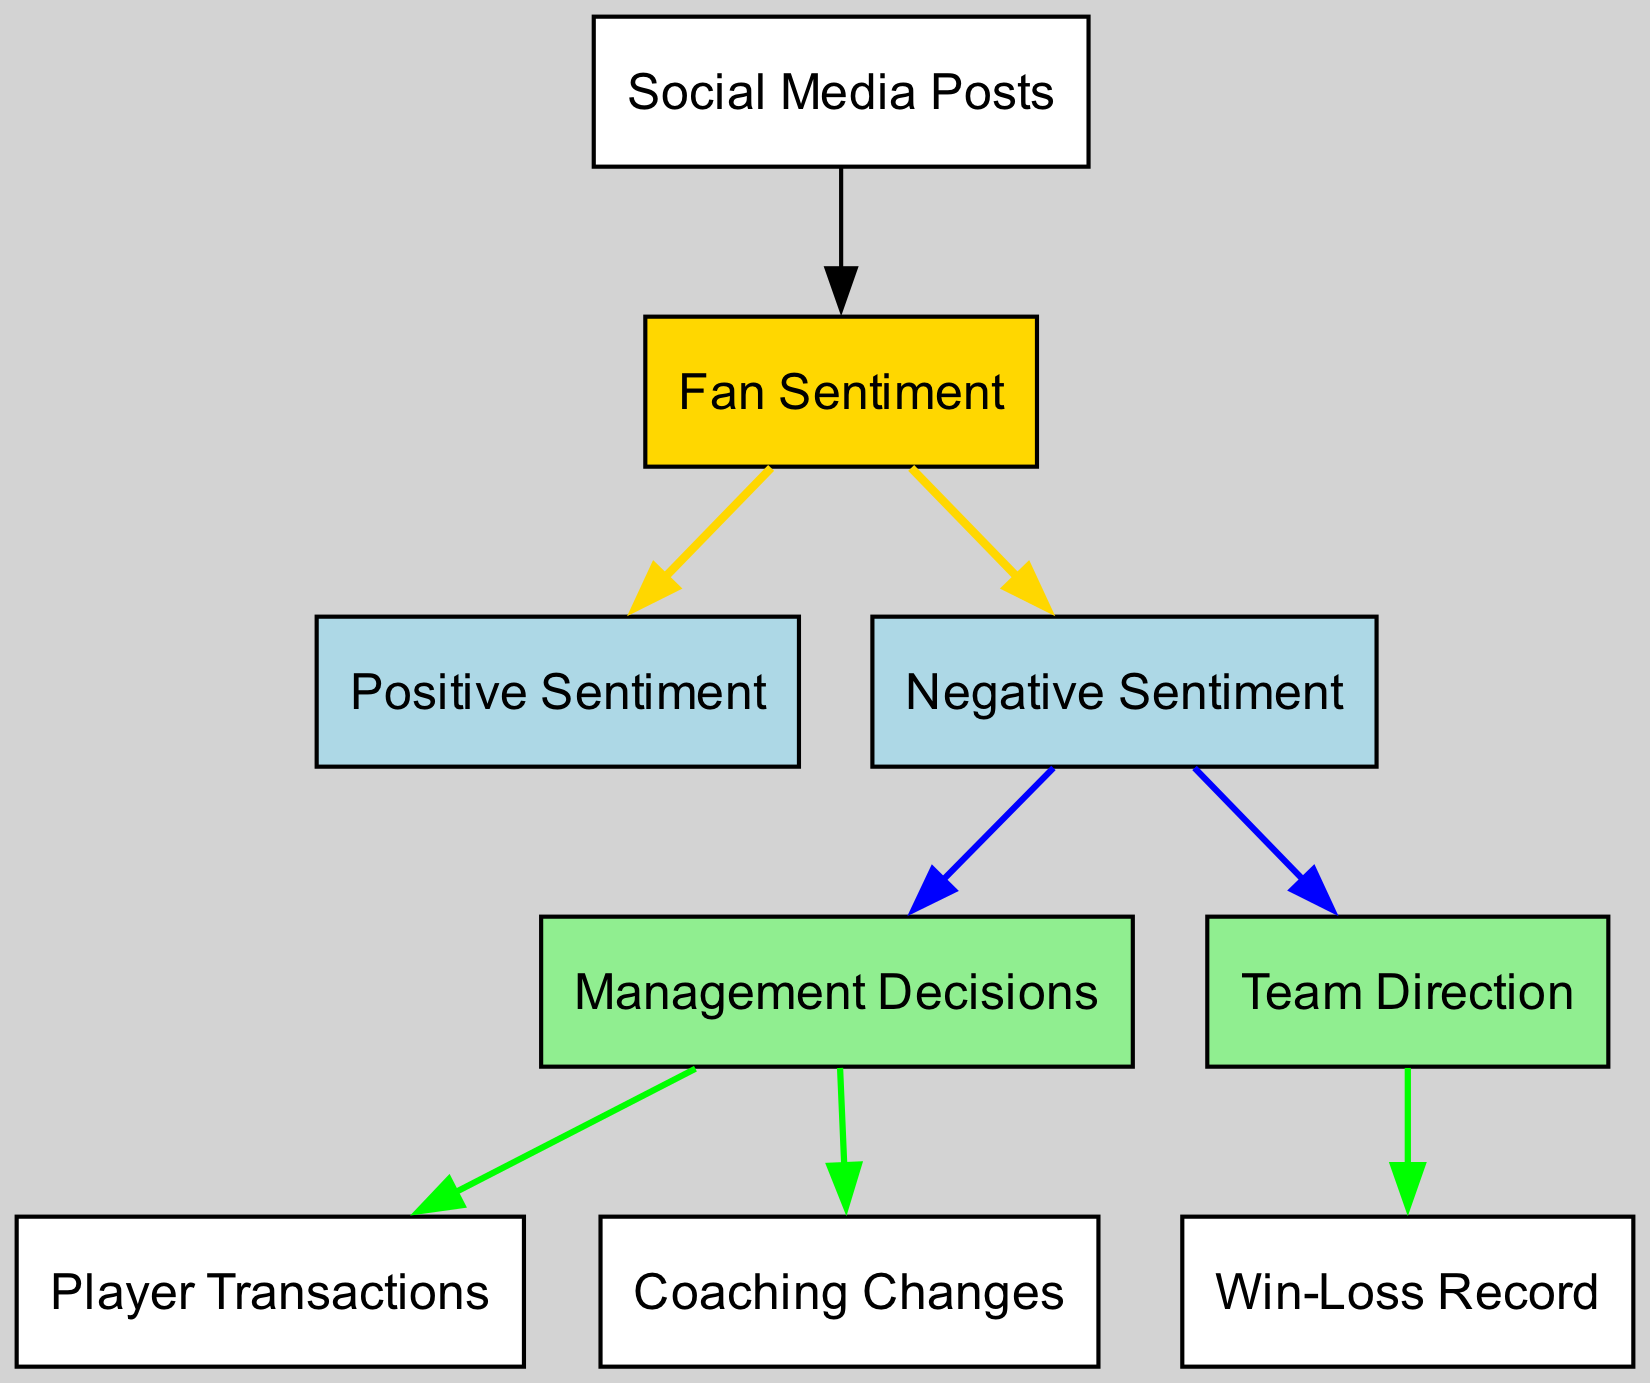What are the total number of nodes in the diagram? By counting, there are 9 distinct nodes listed in the diagram, each representing different aspects of fan sentiment and management decisions.
Answer: 9 Which node represents the fans' overall emotional response? The node labeled "Fan Sentiment" serves as the primary representation of how fans feel overall.
Answer: Fan Sentiment What type of sentiment is connected to management decisions? The "Negative Sentiment" node has a directed edge leading to "Management Decisions," suggesting a link between negative feelings and management choices.
Answer: Negative Sentiment How many management decisions are indicated in the diagram? There are two nodes linked to management decisions: "Player Transactions" and "Coaching Changes," indicating two types of management decisions.
Answer: 2 What leads to the team's win-loss record in the diagram? The edge from "Team Direction" to "Win-Loss Record" shows that the team's strategic direction impacts its win-loss performance.
Answer: Team Direction Which sentiment is linked to coaching changes? The "Negative Sentiment" node is connected to "Coaching Changes," indicating that negative feelings from fans may relate to changes in coaching staff.
Answer: Negative Sentiment What color is used for the "Management Decisions" node? The "Management Decisions" node is represented in light green, distinguishing it visually from other elements.
Answer: Light green Which two nodes are direct consequences of fan sentiment according to the diagram? Both "Positive Sentiment" and "Negative Sentiment" are directly linked to the central "Fan Sentiment" node, indicating different emotional reactions from fans.
Answer: Positive Sentiment and Negative Sentiment How does fan sentiment influence social media posts? The directed edge indicates that "Social Media Posts" feed into the "Fan Sentiment," suggesting that posts reflect and influence how fans feel overall.
Answer: Social Media Posts 